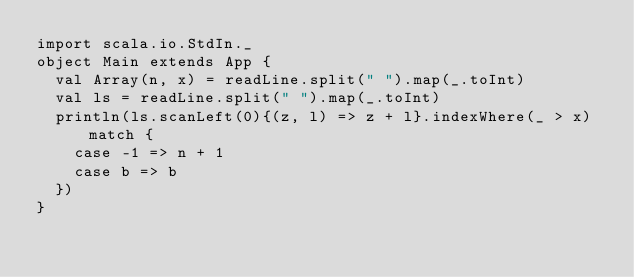Convert code to text. <code><loc_0><loc_0><loc_500><loc_500><_Scala_>import scala.io.StdIn._
object Main extends App {
  val Array(n, x) = readLine.split(" ").map(_.toInt)
  val ls = readLine.split(" ").map(_.toInt)
  println(ls.scanLeft(0){(z, l) => z + l}.indexWhere(_ > x) match {
    case -1 => n + 1
    case b => b
  })
}</code> 